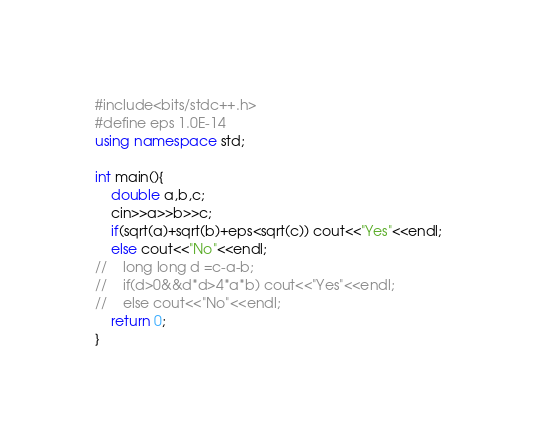Convert code to text. <code><loc_0><loc_0><loc_500><loc_500><_C++_>#include<bits/stdc++.h>
#define eps 1.0E-14
using namespace std;

int main(){
    double a,b,c;
    cin>>a>>b>>c;
    if(sqrt(a)+sqrt(b)+eps<sqrt(c)) cout<<"Yes"<<endl;
    else cout<<"No"<<endl;
//    long long d =c-a-b;
//    if(d>0&&d*d>4*a*b) cout<<"Yes"<<endl;
//    else cout<<"No"<<endl;
    return 0;
}
</code> 